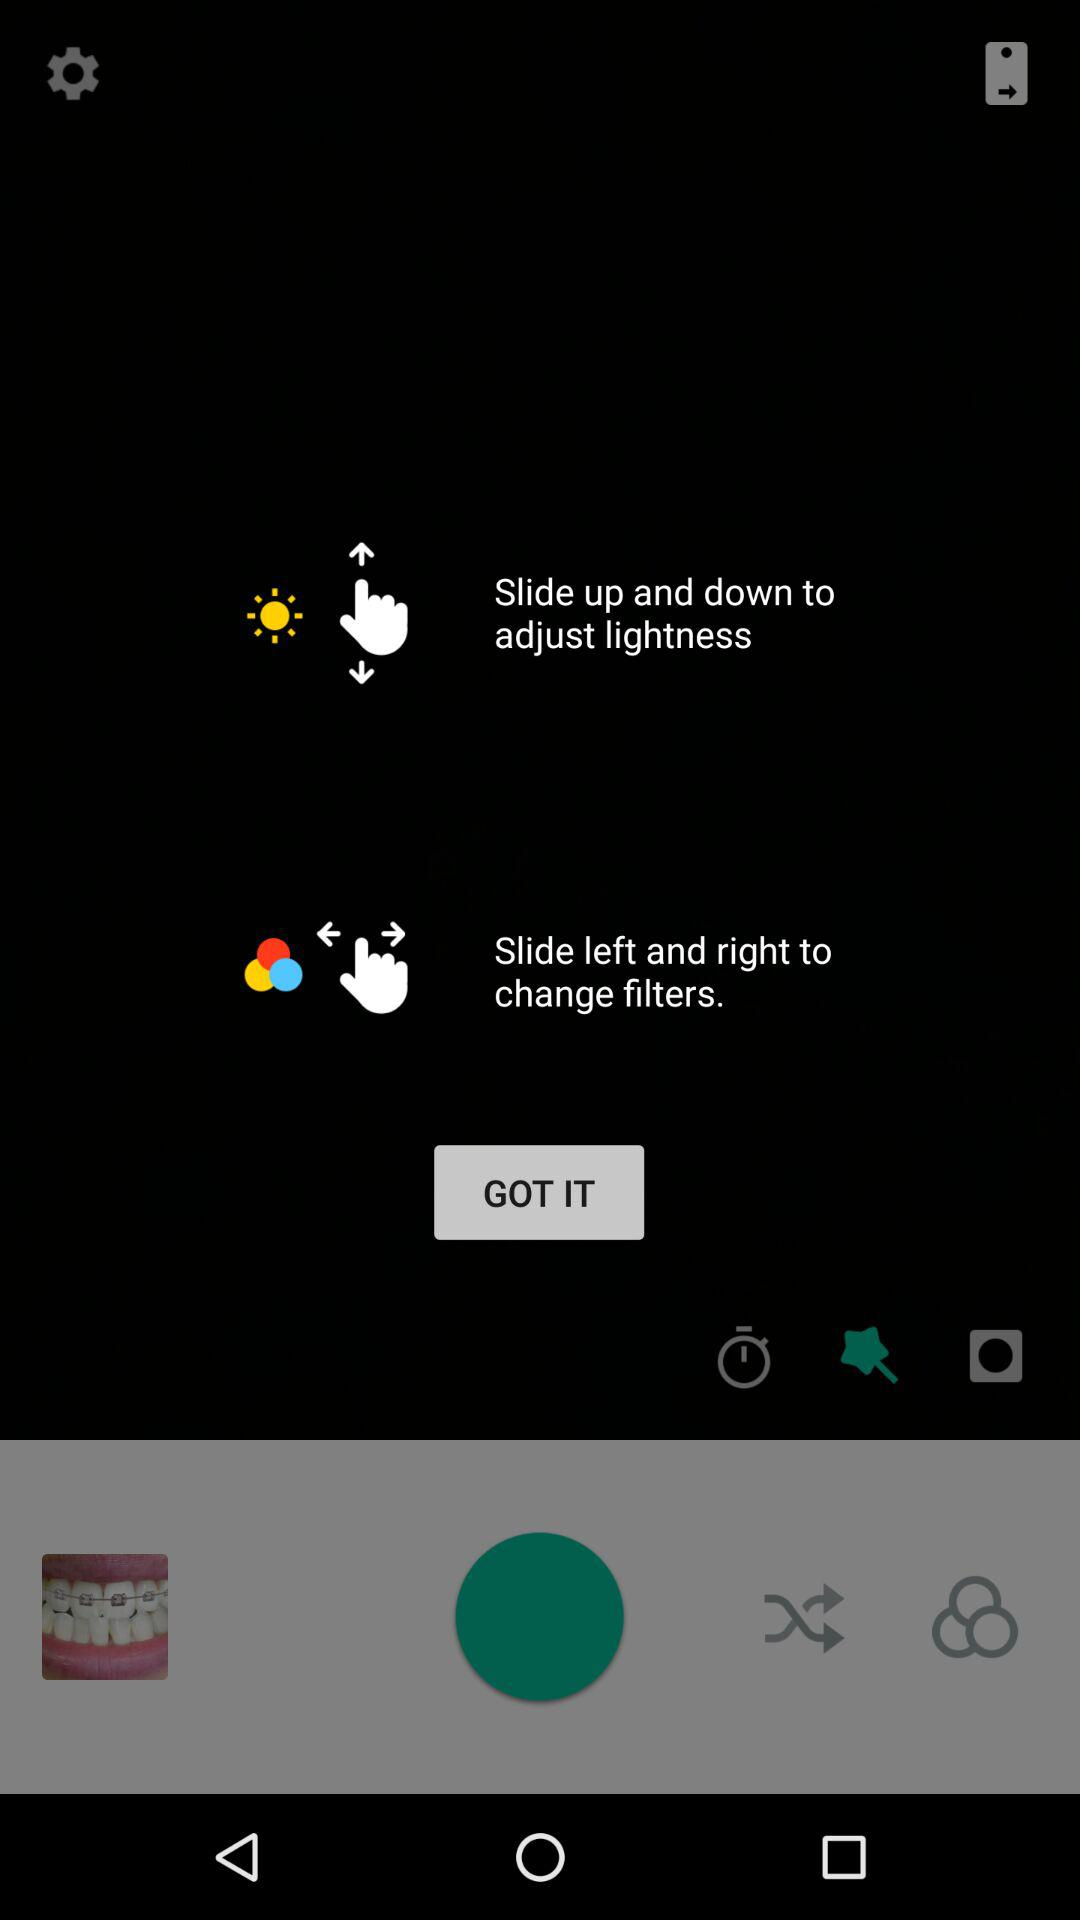On which side do I swipe to change filters? You have to slide left and right to change filters. 